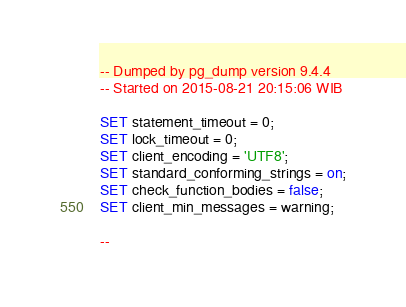Convert code to text. <code><loc_0><loc_0><loc_500><loc_500><_SQL_>-- Dumped by pg_dump version 9.4.4
-- Started on 2015-08-21 20:15:06 WIB

SET statement_timeout = 0;
SET lock_timeout = 0;
SET client_encoding = 'UTF8';
SET standard_conforming_strings = on;
SET check_function_bodies = false;
SET client_min_messages = warning;

--</code> 